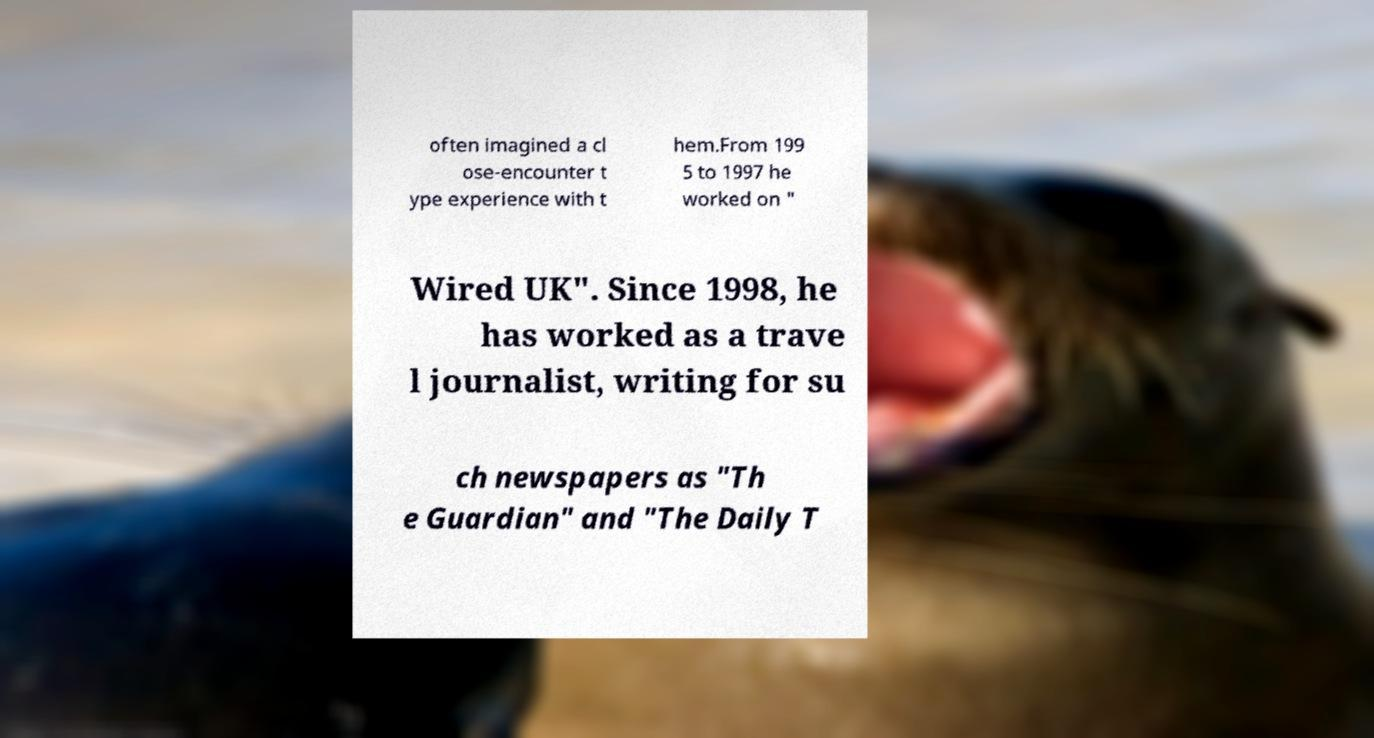Could you assist in decoding the text presented in this image and type it out clearly? often imagined a cl ose-encounter t ype experience with t hem.From 199 5 to 1997 he worked on " Wired UK". Since 1998, he has worked as a trave l journalist, writing for su ch newspapers as "Th e Guardian" and "The Daily T 